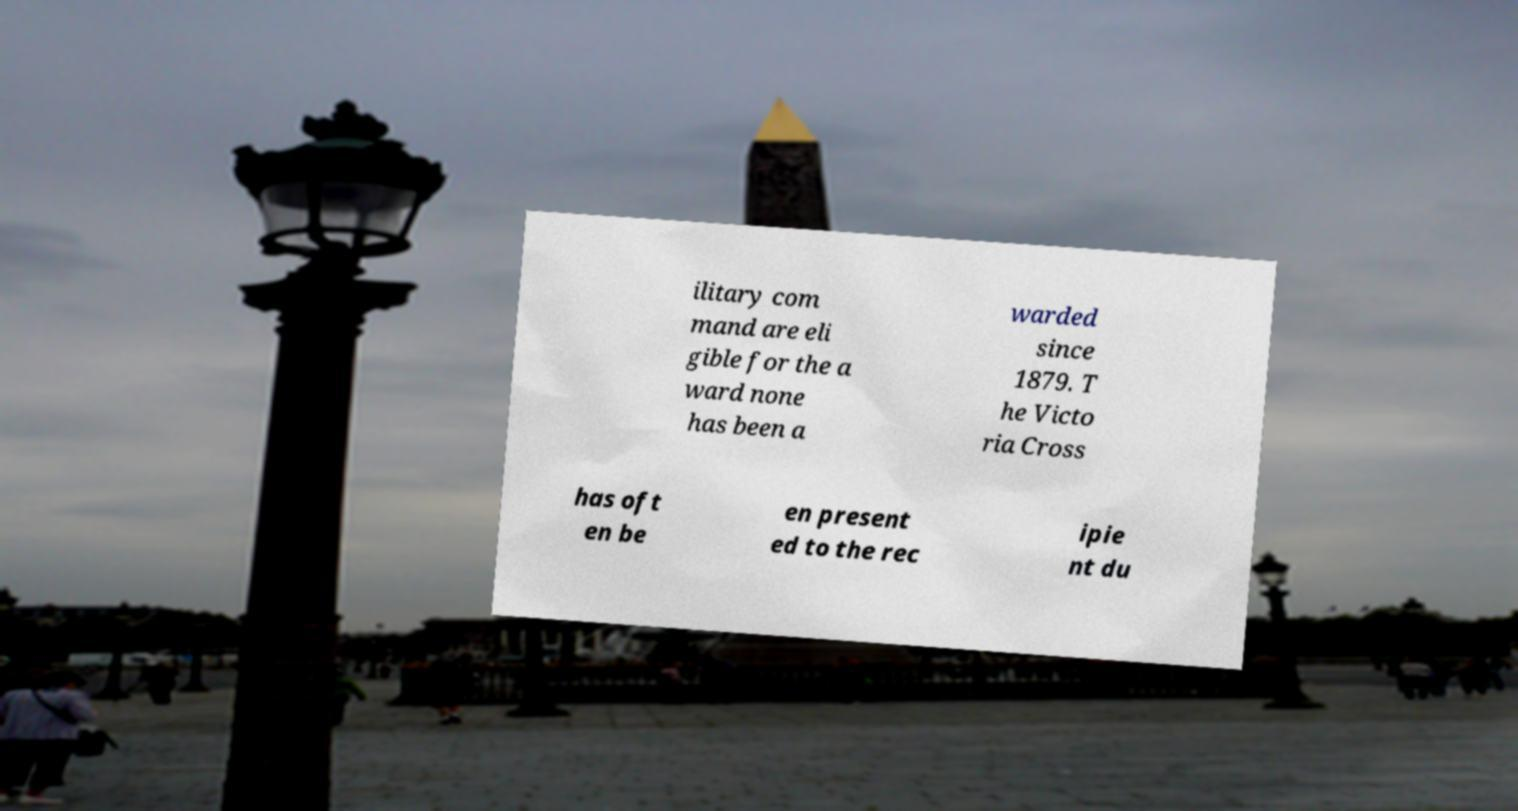What messages or text are displayed in this image? I need them in a readable, typed format. ilitary com mand are eli gible for the a ward none has been a warded since 1879. T he Victo ria Cross has oft en be en present ed to the rec ipie nt du 